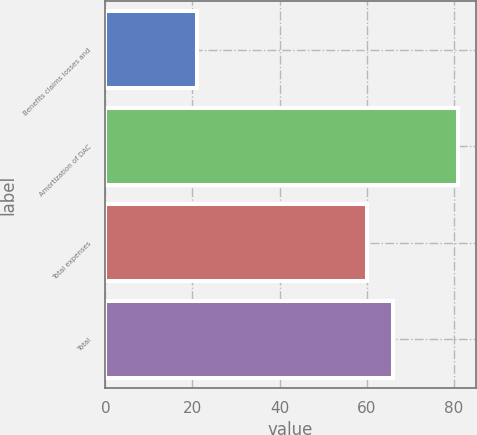Convert chart. <chart><loc_0><loc_0><loc_500><loc_500><bar_chart><fcel>Benefits claims losses and<fcel>Amortization of DAC<fcel>Total expenses<fcel>Total<nl><fcel>21<fcel>81<fcel>60<fcel>66<nl></chart> 